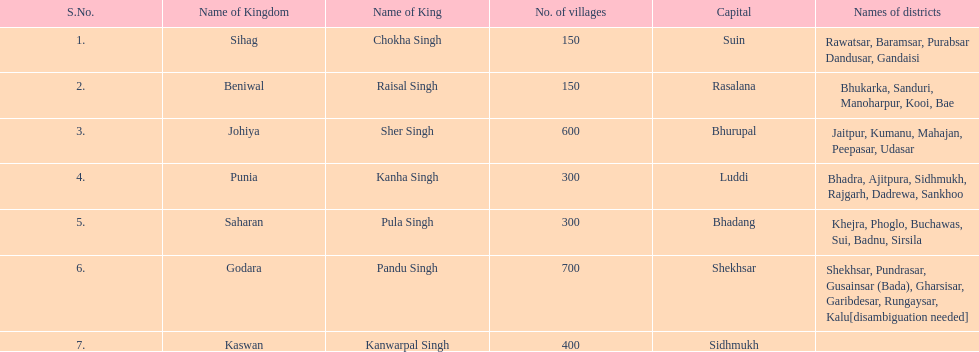What is the count of districts within punia? 6. 